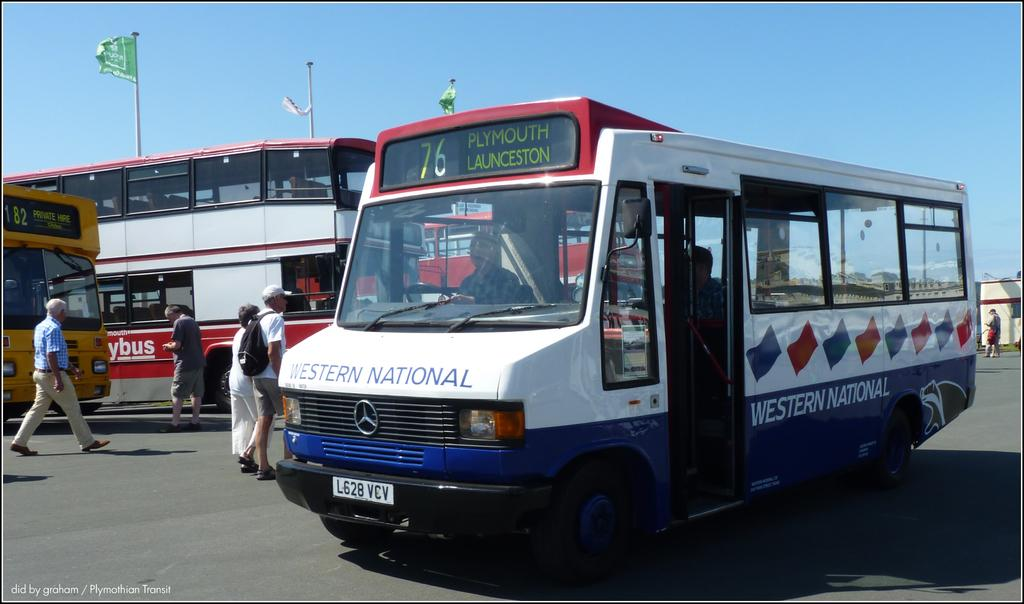What type of vehicles can be seen on the road in the image? There are buses on the road in the image. What are the people in the image doing? There are people walking in the image. What structure is visible in the image? There is a building visible in the image. What decorative elements can be seen in the image? There are flags on poles in the image. What is visible in the background of the image? The sky is visible in the image. What type of powder can be seen covering the buses in the image? There is no powder visible in the image; the buses are not covered in any substance. Is there a volcano erupting in the background of the image? There is no volcano present in the image; it features buses, people walking, a building, flags, and the sky. 